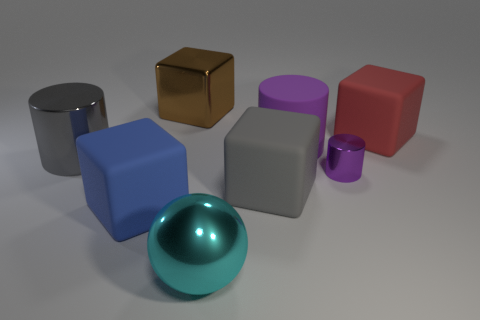Can you tell me which object stands out the most and why? The object that stands out the most is the reflective teal sphere. Its unique shape, a perfect sphere, and the reflective surface make it visually distinctive from the matte-textured cubes and cylinders surrounding it. Does the lighting have anything to do with how the objects are perceived? Absolutely, the lighting plays a significant role in the perception of the objects. It creates highlights and shadows that define the shapes of the objects, enhances the texture differences, and gives the scene depth. The reflective surfaces, like that of the sphere, catch the light more prominently which helps them to stand out. 